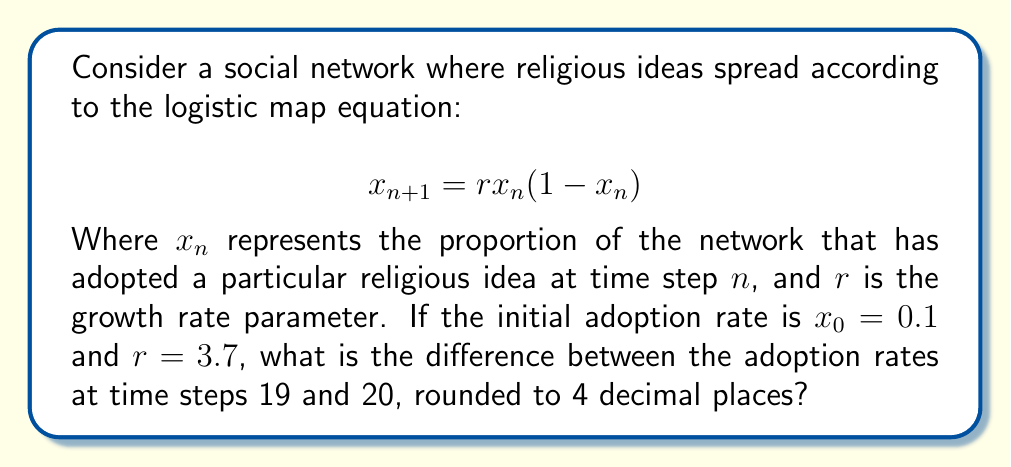What is the answer to this math problem? To solve this problem, we need to iterate the logistic map equation for 20 time steps:

1) Start with $x_0 = 0.1$ and $r = 3.7$

2) For each step, calculate $x_{n+1} = 3.7x_n(1-x_n)$

3) Iterate this process 20 times:

   $x_1 = 3.7(0.1)(1-0.1) = 0.333$
   $x_2 = 3.7(0.333)(1-0.333) = 0.8217$
   $x_3 = 3.7(0.8217)(1-0.8217) = 0.5412$
   ...
   $x_{18} = 0.3538$
   $x_{19} = 0.8449$
   $x_{20} = 0.4845$

4) Calculate the difference between $x_{19}$ and $x_{20}$:

   $|x_{19} - x_{20}| = |0.8449 - 0.4845| = 0.3604$

5) Round to 4 decimal places: 0.3604

This demonstrates the butterfly effect in the spread of religious ideas, as small changes in initial conditions or parameters can lead to significantly different outcomes over time.
Answer: 0.3604 